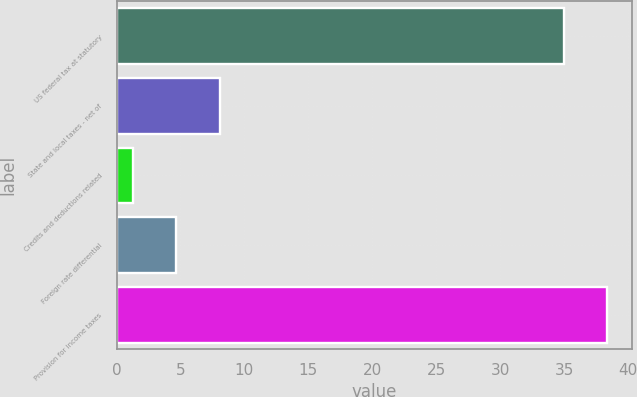<chart> <loc_0><loc_0><loc_500><loc_500><bar_chart><fcel>US federal tax at statutory<fcel>State and local taxes - net of<fcel>Credits and deductions related<fcel>Foreign rate differential<fcel>Provision for income taxes<nl><fcel>35<fcel>8.06<fcel>1.3<fcel>4.68<fcel>38.38<nl></chart> 